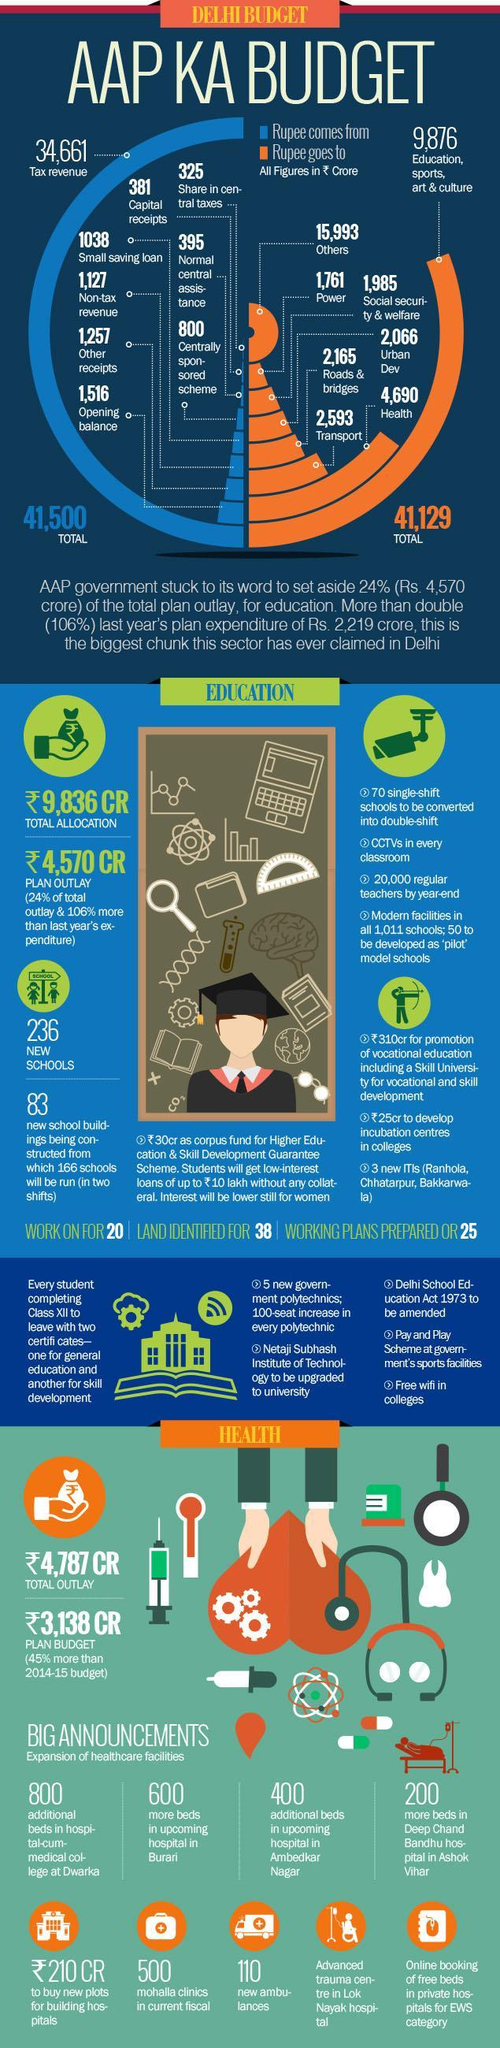What is the Total Revenue in ₹ Crores according to the infographic?
Answer the question with a short phrase. 41,500 How much more expenditure in ₹ Crores was allocated to plan outlay in education than the previous year? 106% What is the Revenue in ₹ Crores from Capital receipts and other receipts put together? 1,638 How much is the Expenditure allocation in ₹ Crores   for land to build hospitals on? 210 What is the Expenditure in ₹ Crores for Health, social security & welfare put together? 6,675 What is the Expenditure allocation for education in ₹ Crores? 9,836 What is the amount that comes from Tax revenue in ₹ Crores? 34,661 What is the Expenditure in ₹ Crores for Transport, Roads and bridges put together? 4,758 What is the Total Expenditure in ₹ Crores according to the infographic? 41,129 Which sector does the money comes from the most? Tax revenue 